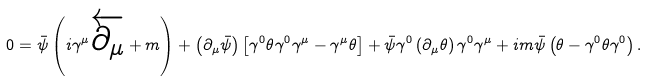Convert formula to latex. <formula><loc_0><loc_0><loc_500><loc_500>0 = \bar { \psi } \left ( i \gamma ^ { \mu } \overleftarrow { \partial _ { \mu } } + m \right ) + \left ( \partial _ { \mu } \bar { \psi } \right ) \left [ \gamma ^ { 0 } \theta \gamma ^ { 0 } \gamma ^ { \mu } - \gamma ^ { \mu } \theta \right ] + \bar { \psi } \gamma ^ { 0 } \left ( \partial _ { \mu } \theta \right ) \gamma ^ { 0 } \gamma ^ { \mu } + i m \bar { \psi } \left ( \theta - \gamma ^ { 0 } \theta \gamma ^ { 0 } \right ) .</formula> 